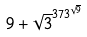Convert formula to latex. <formula><loc_0><loc_0><loc_500><loc_500>9 + \sqrt { 3 } ^ { 3 7 3 ^ { \sqrt { 9 } } }</formula> 